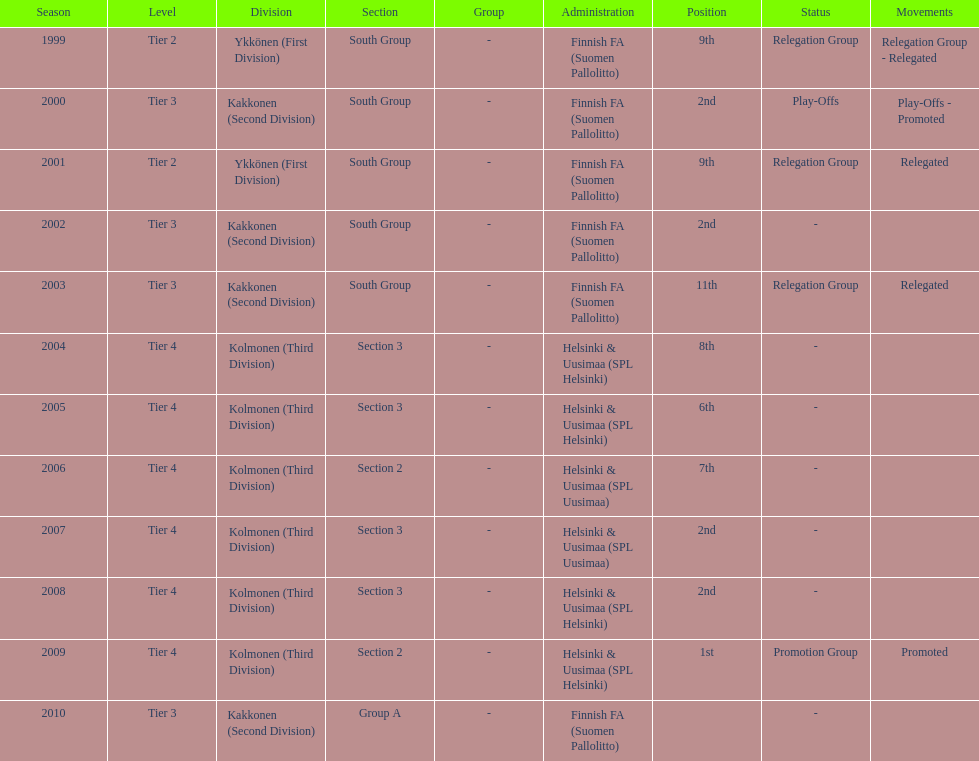What division were they in the most, section 3 or 2? 3. 